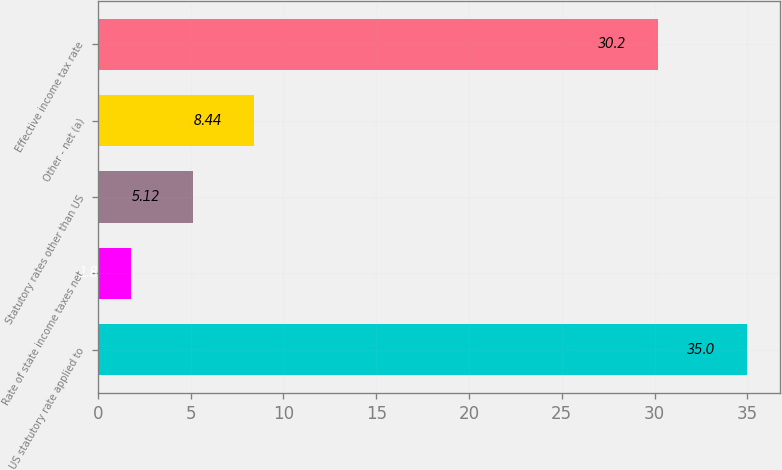Convert chart. <chart><loc_0><loc_0><loc_500><loc_500><bar_chart><fcel>US statutory rate applied to<fcel>Rate of state income taxes net<fcel>Statutory rates other than US<fcel>Other - net (a)<fcel>Effective income tax rate<nl><fcel>35<fcel>1.8<fcel>5.12<fcel>8.44<fcel>30.2<nl></chart> 